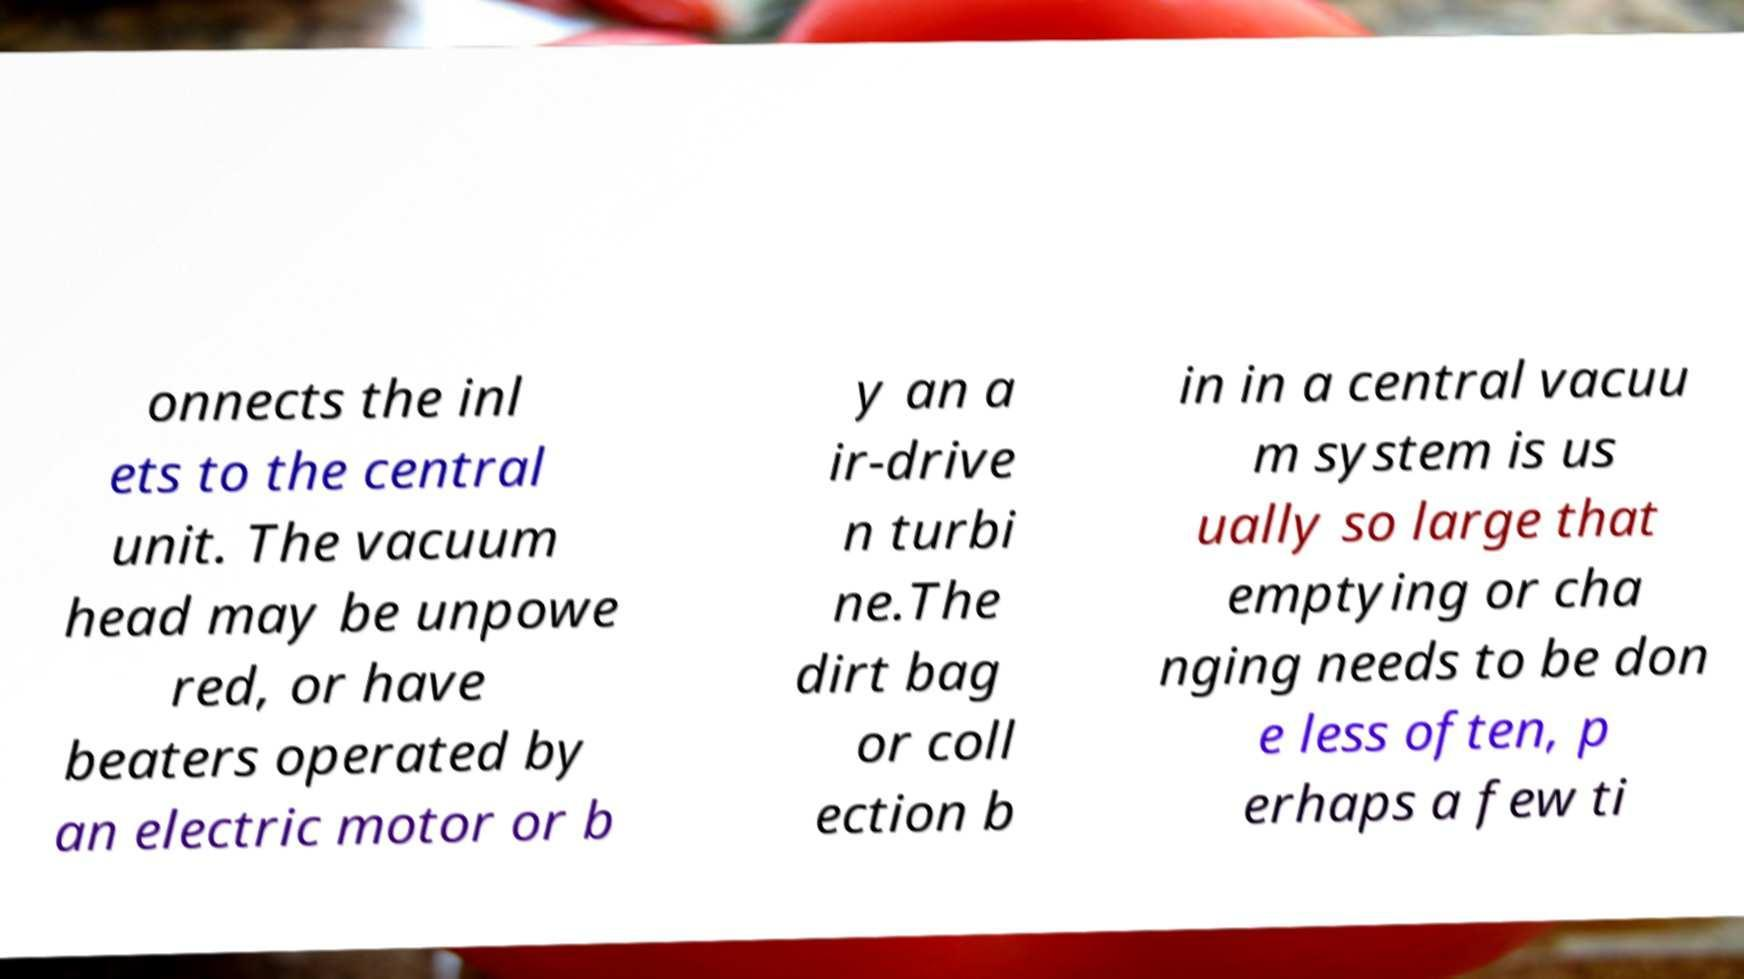I need the written content from this picture converted into text. Can you do that? onnects the inl ets to the central unit. The vacuum head may be unpowe red, or have beaters operated by an electric motor or b y an a ir-drive n turbi ne.The dirt bag or coll ection b in in a central vacuu m system is us ually so large that emptying or cha nging needs to be don e less often, p erhaps a few ti 